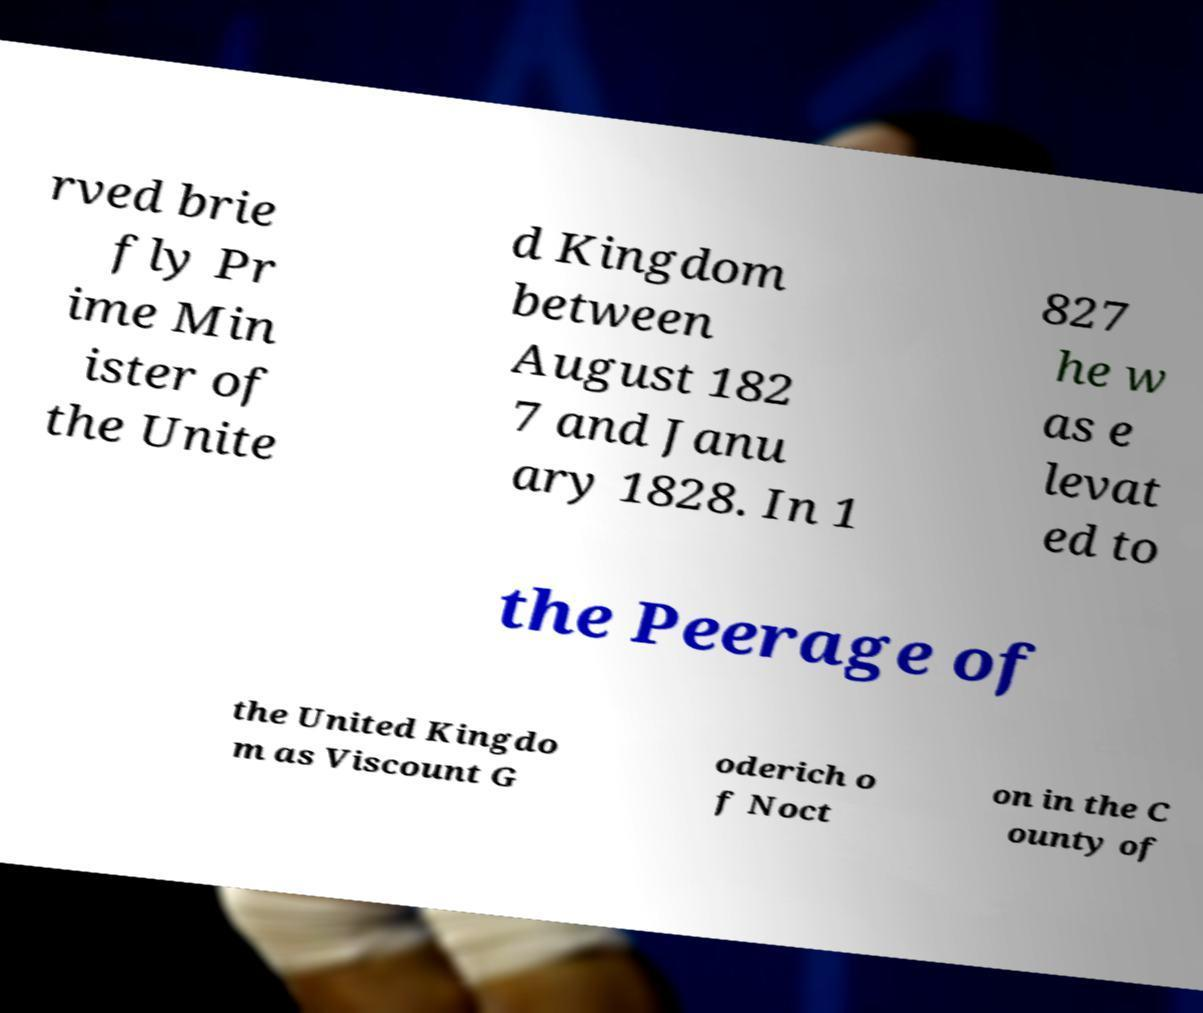For documentation purposes, I need the text within this image transcribed. Could you provide that? rved brie fly Pr ime Min ister of the Unite d Kingdom between August 182 7 and Janu ary 1828. In 1 827 he w as e levat ed to the Peerage of the United Kingdo m as Viscount G oderich o f Noct on in the C ounty of 